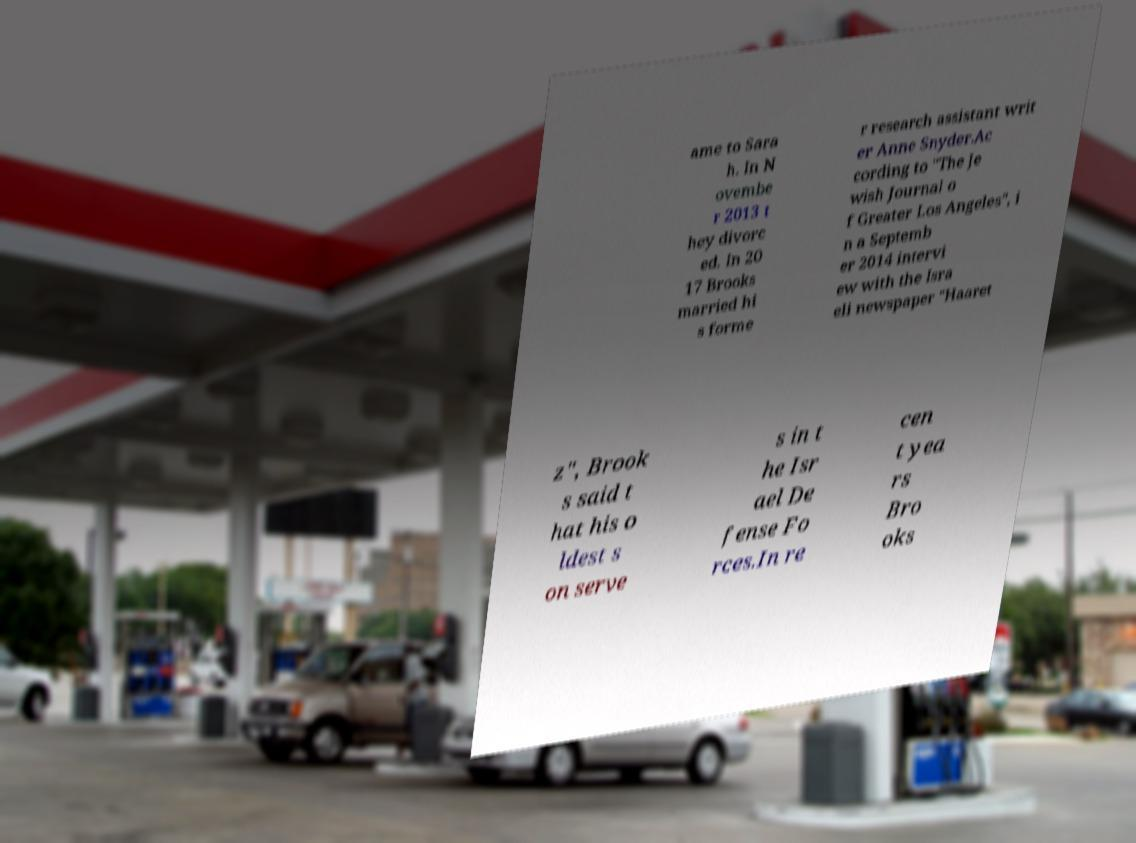Could you extract and type out the text from this image? ame to Sara h. In N ovembe r 2013 t hey divorc ed. In 20 17 Brooks married hi s forme r research assistant writ er Anne Snyder.Ac cording to "The Je wish Journal o f Greater Los Angeles", i n a Septemb er 2014 intervi ew with the Isra eli newspaper "Haaret z", Brook s said t hat his o ldest s on serve s in t he Isr ael De fense Fo rces.In re cen t yea rs Bro oks 